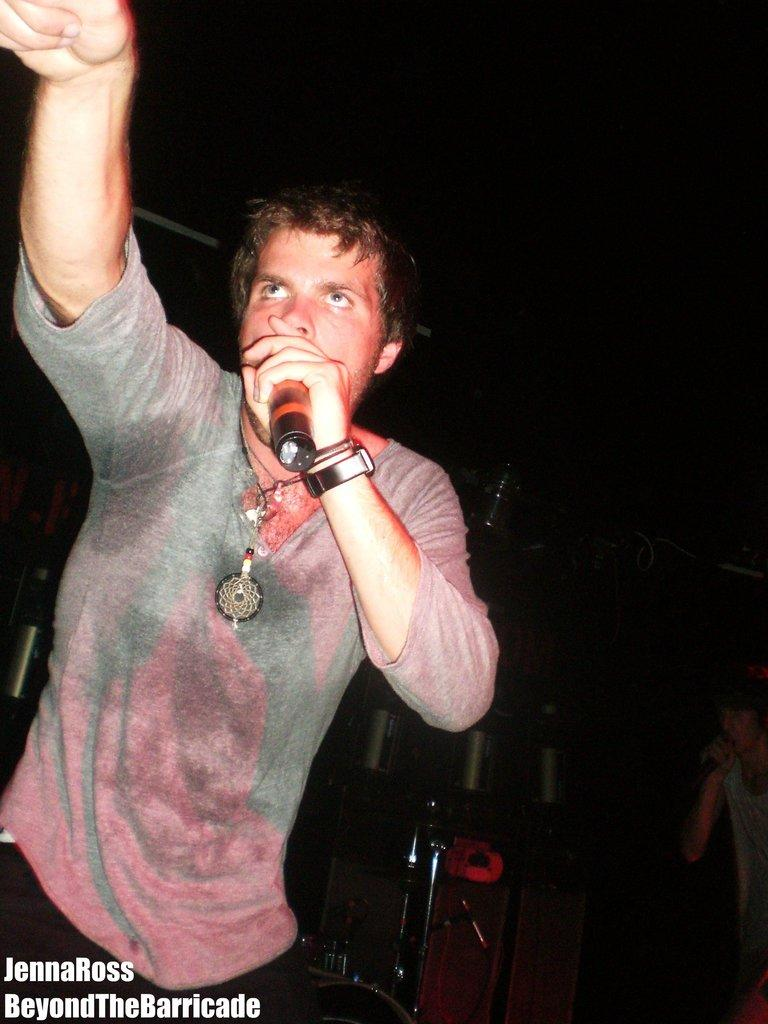Who or what is the main subject of the image? There is a person in the image. What is the person holding in the image? The person is holding a microphone. What can be seen at the bottom of the image? There is text visible at the bottom of the image. How would you describe the overall lighting in the image? The background of the image is dark. What type of pleasure can be seen cooking on the stove in the image? There is no stove or pleasure present in the image; it features a person holding a microphone with a dark background. 